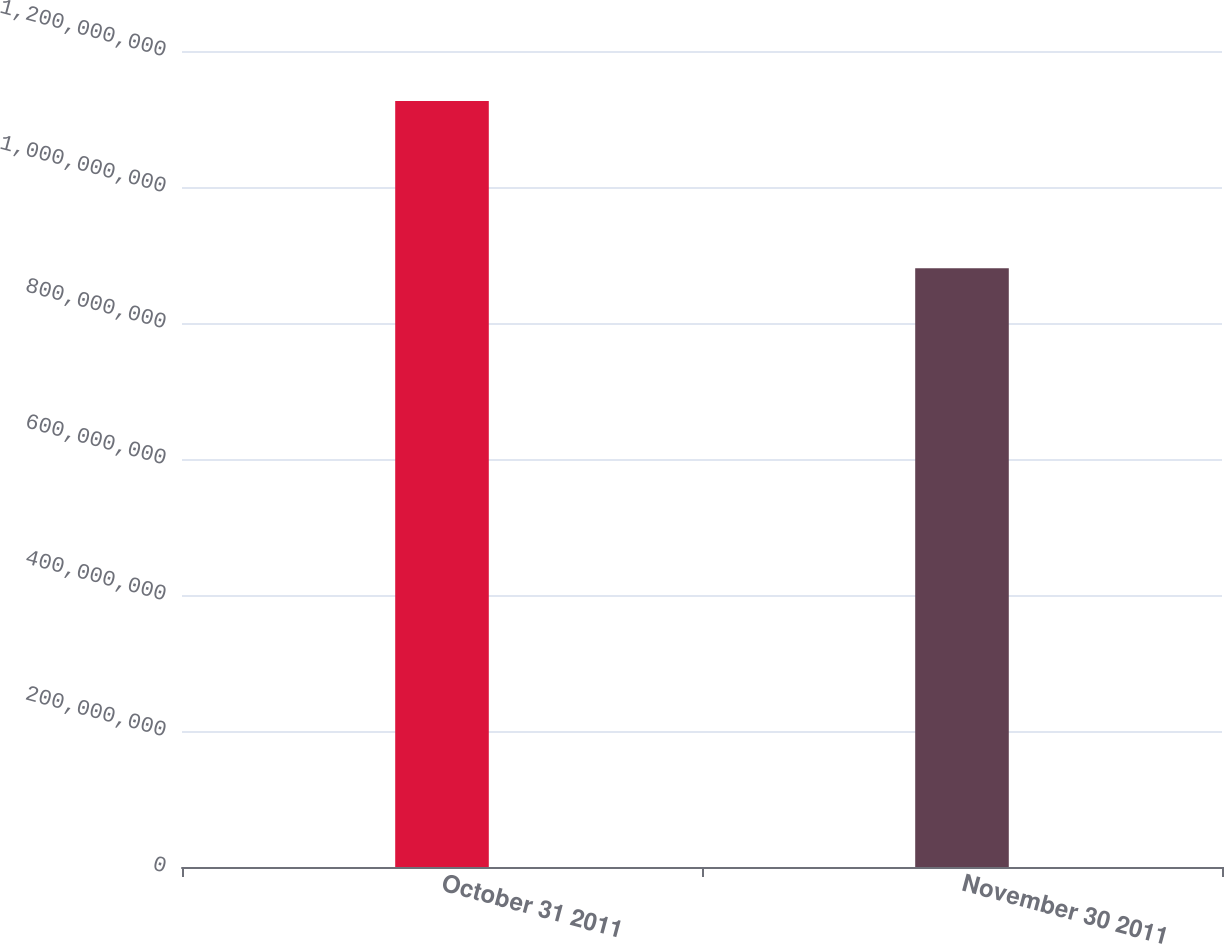<chart> <loc_0><loc_0><loc_500><loc_500><bar_chart><fcel>October 31 2011<fcel>November 30 2011<nl><fcel>1.12659e+09<fcel>8.80522e+08<nl></chart> 